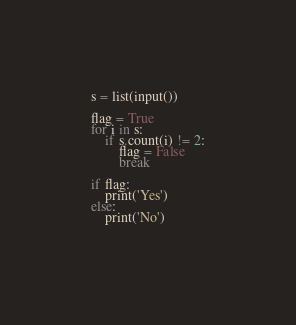<code> <loc_0><loc_0><loc_500><loc_500><_Python_>s = list(input())

flag = True
for i in s:
    if s.count(i) != 2:
        flag = False
        break

if flag:
    print('Yes')
else:
    print('No')
            
</code> 